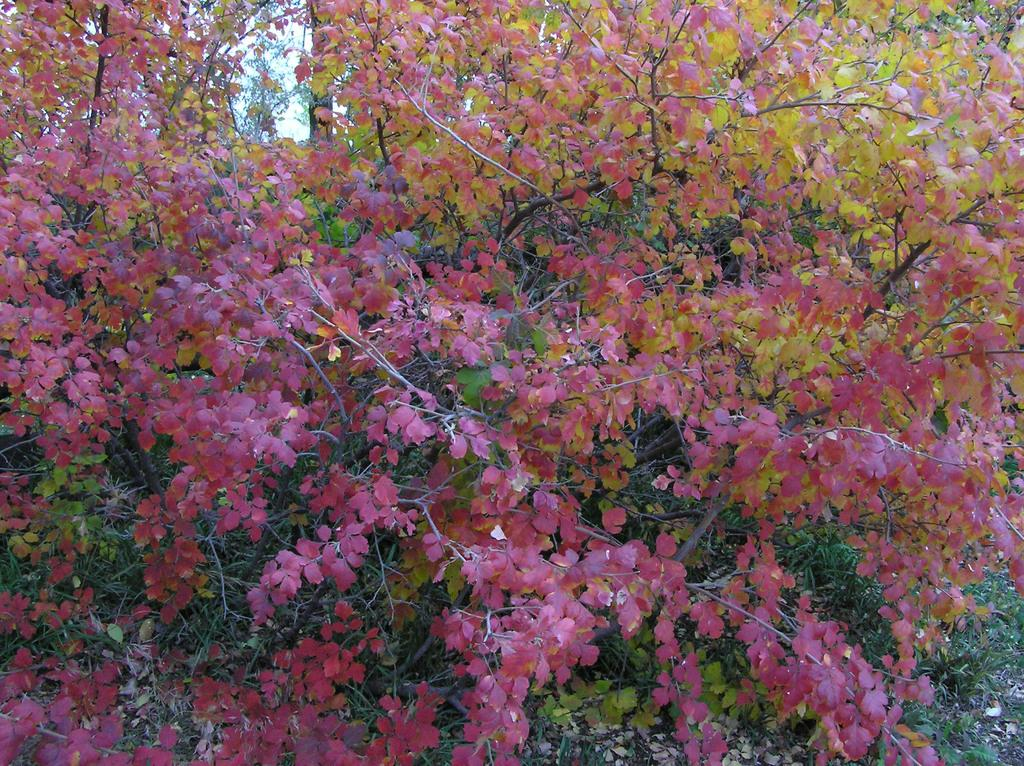What type of vegetation is visible in the front of the image? There are trees and leaves in the front of the image. What part of the natural environment can be seen in the background of the image? The sky is visible in the background of the image. What is the opinion of the tooth about the journey in the image? There is no tooth or journey present in the image, so it is not possible to determine the tooth's opinion. 